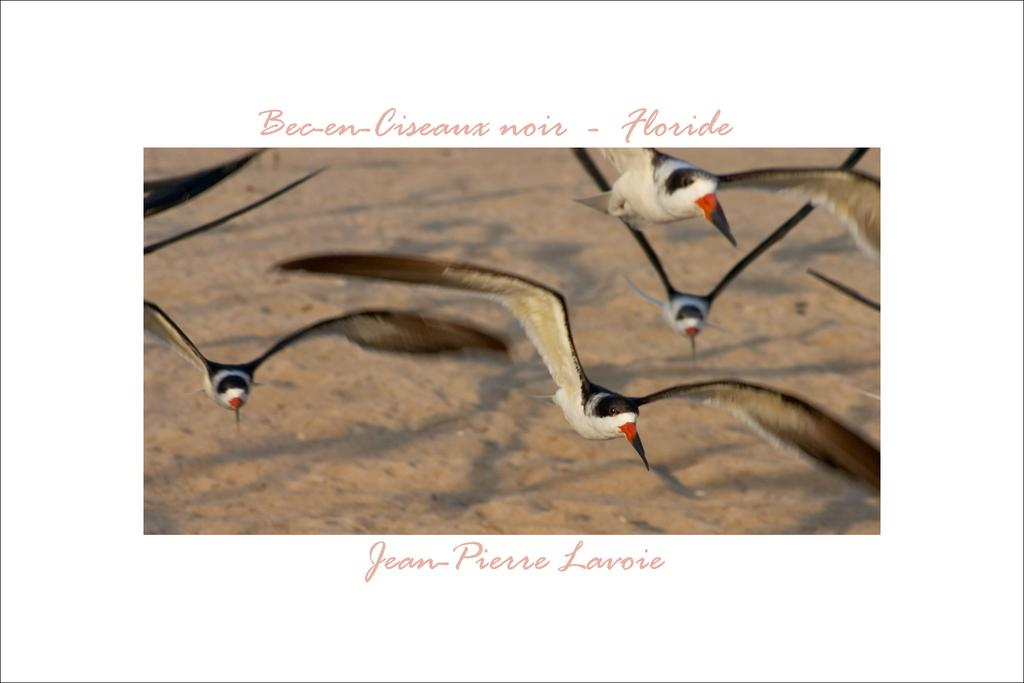What is featured in the image? There is a poster in the image. What is shown on the poster? The poster depicts birds flying in the sky. What type of waste is visible in the image? There is no waste visible in the image; it only features a poster with birds flying in the sky. 